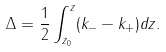Convert formula to latex. <formula><loc_0><loc_0><loc_500><loc_500>\Delta = \frac { 1 } { 2 } \int ^ { z } _ { z _ { 0 } } ( k _ { - } - k _ { + } ) d z .</formula> 